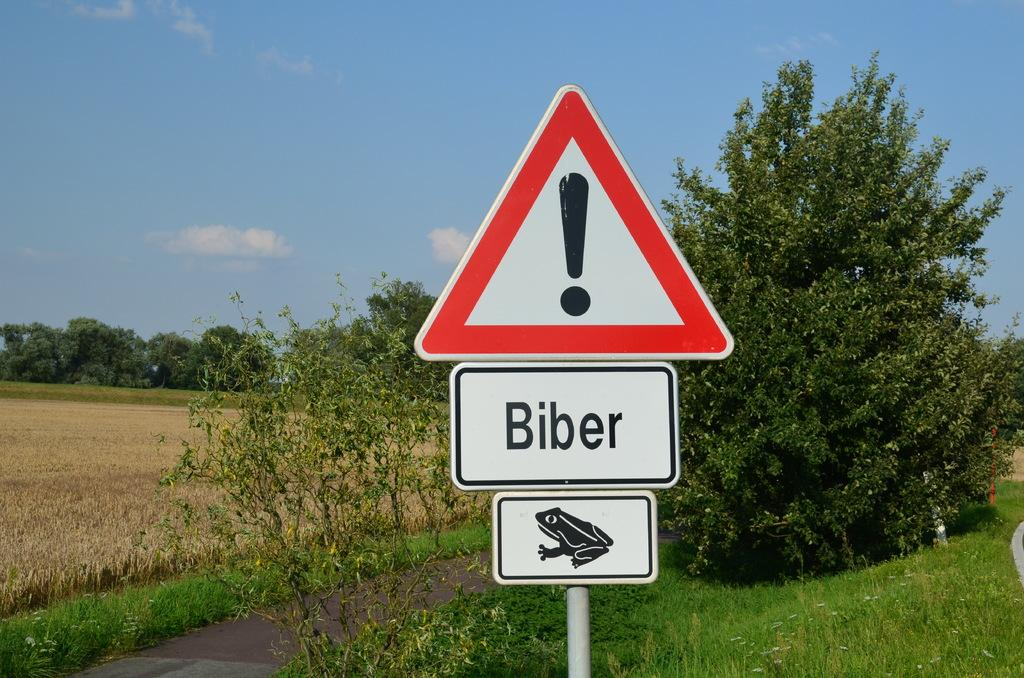<image>
Share a concise interpretation of the image provided. a yeild sign with the word Biber and a frog is by the road 